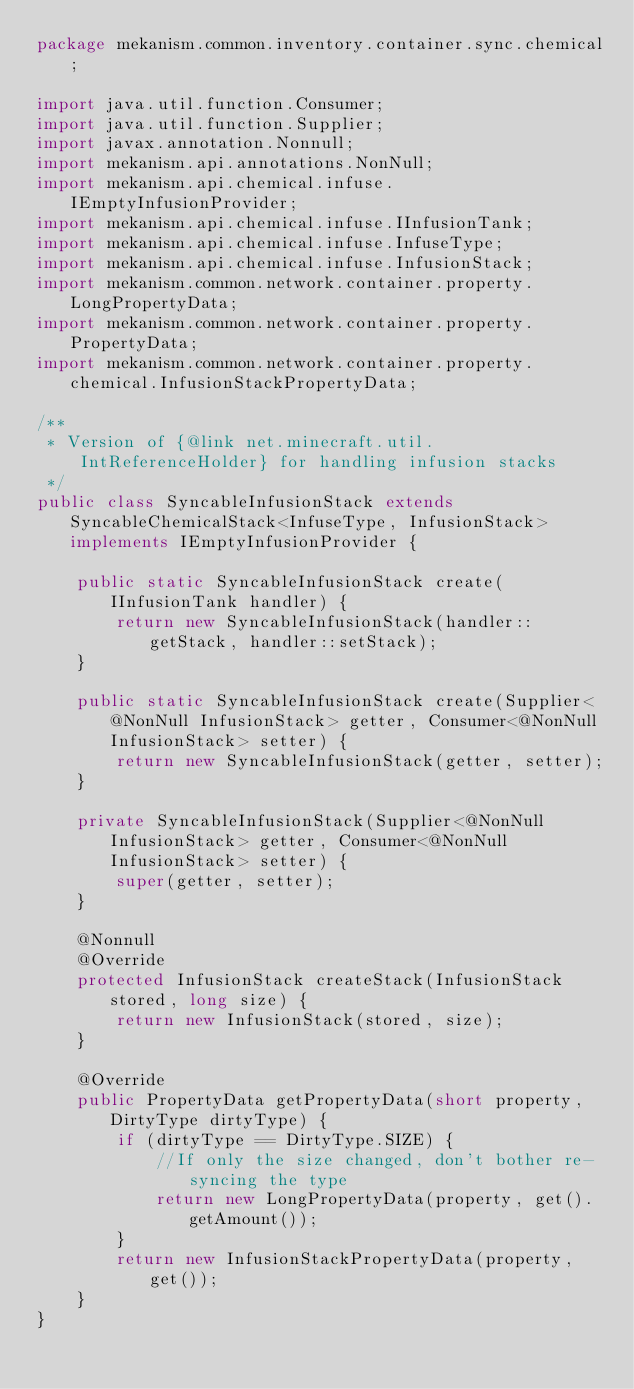Convert code to text. <code><loc_0><loc_0><loc_500><loc_500><_Java_>package mekanism.common.inventory.container.sync.chemical;

import java.util.function.Consumer;
import java.util.function.Supplier;
import javax.annotation.Nonnull;
import mekanism.api.annotations.NonNull;
import mekanism.api.chemical.infuse.IEmptyInfusionProvider;
import mekanism.api.chemical.infuse.IInfusionTank;
import mekanism.api.chemical.infuse.InfuseType;
import mekanism.api.chemical.infuse.InfusionStack;
import mekanism.common.network.container.property.LongPropertyData;
import mekanism.common.network.container.property.PropertyData;
import mekanism.common.network.container.property.chemical.InfusionStackPropertyData;

/**
 * Version of {@link net.minecraft.util.IntReferenceHolder} for handling infusion stacks
 */
public class SyncableInfusionStack extends SyncableChemicalStack<InfuseType, InfusionStack> implements IEmptyInfusionProvider {

    public static SyncableInfusionStack create(IInfusionTank handler) {
        return new SyncableInfusionStack(handler::getStack, handler::setStack);
    }

    public static SyncableInfusionStack create(Supplier<@NonNull InfusionStack> getter, Consumer<@NonNull InfusionStack> setter) {
        return new SyncableInfusionStack(getter, setter);
    }

    private SyncableInfusionStack(Supplier<@NonNull InfusionStack> getter, Consumer<@NonNull InfusionStack> setter) {
        super(getter, setter);
    }

    @Nonnull
    @Override
    protected InfusionStack createStack(InfusionStack stored, long size) {
        return new InfusionStack(stored, size);
    }

    @Override
    public PropertyData getPropertyData(short property, DirtyType dirtyType) {
        if (dirtyType == DirtyType.SIZE) {
            //If only the size changed, don't bother re-syncing the type
            return new LongPropertyData(property, get().getAmount());
        }
        return new InfusionStackPropertyData(property, get());
    }
}</code> 